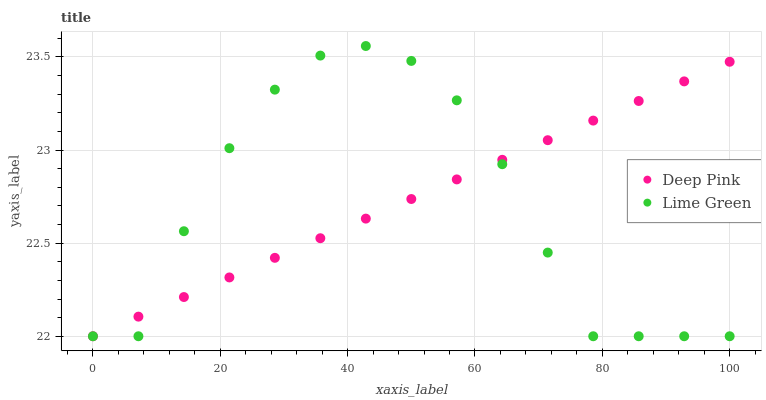Does Lime Green have the minimum area under the curve?
Answer yes or no. Yes. Does Deep Pink have the maximum area under the curve?
Answer yes or no. Yes. Does Lime Green have the maximum area under the curve?
Answer yes or no. No. Is Deep Pink the smoothest?
Answer yes or no. Yes. Is Lime Green the roughest?
Answer yes or no. Yes. Is Lime Green the smoothest?
Answer yes or no. No. Does Deep Pink have the lowest value?
Answer yes or no. Yes. Does Lime Green have the highest value?
Answer yes or no. Yes. Does Deep Pink intersect Lime Green?
Answer yes or no. Yes. Is Deep Pink less than Lime Green?
Answer yes or no. No. Is Deep Pink greater than Lime Green?
Answer yes or no. No. 